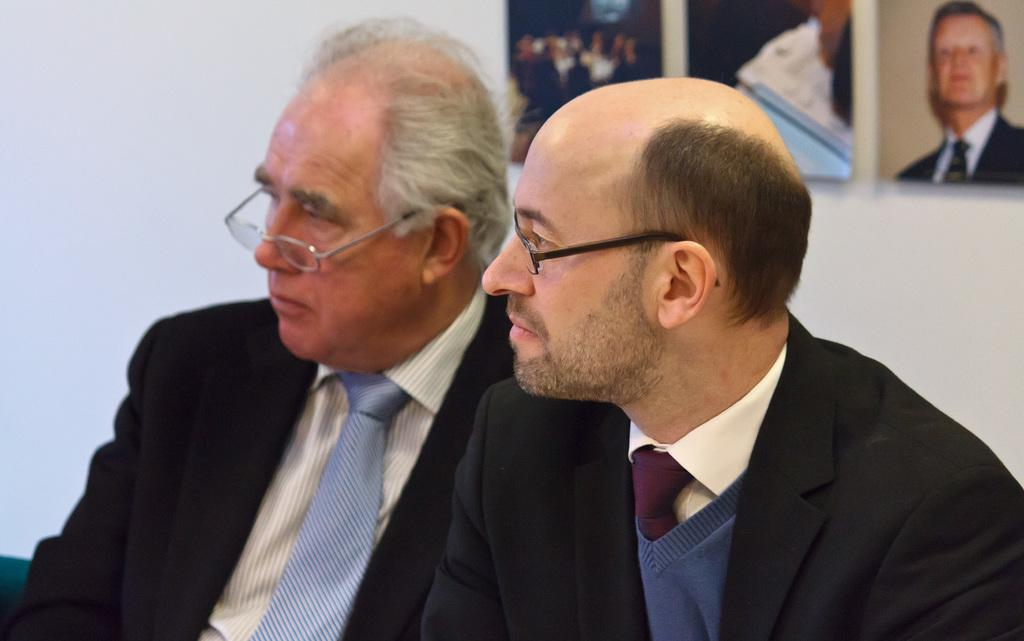How many people are in the image? There are two persons in the image. What are the people wearing that is common to both of them? Both persons are wearing glasses. What can be seen behind the people in the image? There is a plain wall in the background. What is attached to the wall in the image? There are frames attached to the wall. What type of waste can be seen on the floor in the image? There is no waste visible on the floor in the image. How many horses are present in the image? There are no horses present in the image. 